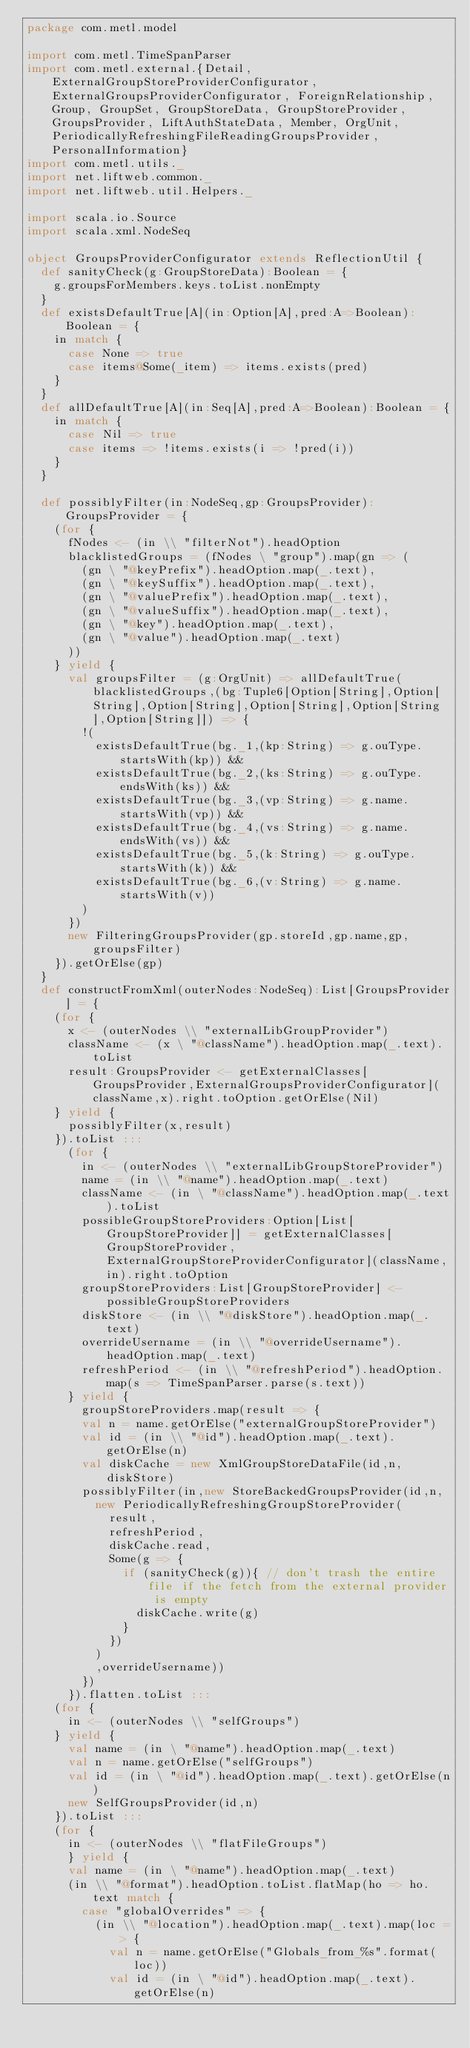Convert code to text. <code><loc_0><loc_0><loc_500><loc_500><_Scala_>package com.metl.model

import com.metl.TimeSpanParser
import com.metl.external.{Detail, ExternalGroupStoreProviderConfigurator, ExternalGroupsProviderConfigurator, ForeignRelationship, Group, GroupSet, GroupStoreData, GroupStoreProvider, GroupsProvider, LiftAuthStateData, Member, OrgUnit, PeriodicallyRefreshingFileReadingGroupsProvider, PersonalInformation}
import com.metl.utils._
import net.liftweb.common._
import net.liftweb.util.Helpers._

import scala.io.Source
import scala.xml.NodeSeq

object GroupsProviderConfigurator extends ReflectionUtil {
  def sanityCheck(g:GroupStoreData):Boolean = {
    g.groupsForMembers.keys.toList.nonEmpty
  }
  def existsDefaultTrue[A](in:Option[A],pred:A=>Boolean):Boolean = {
    in match {
      case None => true
      case items@Some(_item) => items.exists(pred)
    }
  }
  def allDefaultTrue[A](in:Seq[A],pred:A=>Boolean):Boolean = {
    in match {
      case Nil => true
      case items => !items.exists(i => !pred(i))
    }
  }

  def possiblyFilter(in:NodeSeq,gp:GroupsProvider):GroupsProvider = {
    (for {
      fNodes <- (in \\ "filterNot").headOption
      blacklistedGroups = (fNodes \ "group").map(gn => (
        (gn \ "@keyPrefix").headOption.map(_.text),
        (gn \ "@keySuffix").headOption.map(_.text),
        (gn \ "@valuePrefix").headOption.map(_.text),
        (gn \ "@valueSuffix").headOption.map(_.text),
        (gn \ "@key").headOption.map(_.text),
        (gn \ "@value").headOption.map(_.text)
      ))
    } yield {
      val groupsFilter = (g:OrgUnit) => allDefaultTrue(blacklistedGroups,(bg:Tuple6[Option[String],Option[String],Option[String],Option[String],Option[String],Option[String]]) => {
        !(
          existsDefaultTrue(bg._1,(kp:String) => g.ouType.startsWith(kp)) &&
          existsDefaultTrue(bg._2,(ks:String) => g.ouType.endsWith(ks)) &&
          existsDefaultTrue(bg._3,(vp:String) => g.name.startsWith(vp)) &&
          existsDefaultTrue(bg._4,(vs:String) => g.name.endsWith(vs)) &&
          existsDefaultTrue(bg._5,(k:String) => g.ouType.startsWith(k)) &&
          existsDefaultTrue(bg._6,(v:String) => g.name.startsWith(v))
        )
      })
      new FilteringGroupsProvider(gp.storeId,gp.name,gp,groupsFilter)
    }).getOrElse(gp)
  }
  def constructFromXml(outerNodes:NodeSeq):List[GroupsProvider] = {
    (for {
      x <- (outerNodes \\ "externalLibGroupProvider")
      className <- (x \ "@className").headOption.map(_.text).toList
      result:GroupsProvider <- getExternalClasses[GroupsProvider,ExternalGroupsProviderConfigurator](className,x).right.toOption.getOrElse(Nil)
    } yield {
      possiblyFilter(x,result)
    }).toList :::
      (for {
        in <- (outerNodes \\ "externalLibGroupStoreProvider")
        name = (in \\ "@name").headOption.map(_.text)
        className <- (in \ "@className").headOption.map(_.text).toList
        possibleGroupStoreProviders:Option[List[GroupStoreProvider]] = getExternalClasses[GroupStoreProvider,ExternalGroupStoreProviderConfigurator](className,in).right.toOption
        groupStoreProviders:List[GroupStoreProvider] <- possibleGroupStoreProviders
        diskStore <- (in \\ "@diskStore").headOption.map(_.text)
        overrideUsername = (in \\ "@overrideUsername").headOption.map(_.text)
        refreshPeriod <- (in \\ "@refreshPeriod").headOption.map(s => TimeSpanParser.parse(s.text))
      } yield {
        groupStoreProviders.map(result => {
        val n = name.getOrElse("externalGroupStoreProvider")
        val id = (in \\ "@id").headOption.map(_.text).getOrElse(n)
        val diskCache = new XmlGroupStoreDataFile(id,n,diskStore)
        possiblyFilter(in,new StoreBackedGroupsProvider(id,n,
          new PeriodicallyRefreshingGroupStoreProvider(
            result,
            refreshPeriod,
            diskCache.read,
            Some(g => {
              if (sanityCheck(g)){ // don't trash the entire file if the fetch from the external provider is empty
                diskCache.write(g)
              }
            })
          )
          ,overrideUsername))
        })
      }).flatten.toList :::
    (for {
      in <- (outerNodes \\ "selfGroups")
    } yield {
      val name = (in \ "@name").headOption.map(_.text)
      val n = name.getOrElse("selfGroups")
      val id = (in \ "@id").headOption.map(_.text).getOrElse(n)
      new SelfGroupsProvider(id,n)
    }).toList :::
    (for {
      in <- (outerNodes \\ "flatFileGroups")
      } yield {
      val name = (in \ "@name").headOption.map(_.text)
      (in \\ "@format").headOption.toList.flatMap(ho => ho.text match {
        case "globalOverrides" => {
          (in \\ "@location").headOption.map(_.text).map(loc => {
            val n = name.getOrElse("Globals_from_%s".format(loc))
            val id = (in \ "@id").headOption.map(_.text).getOrElse(n)</code> 